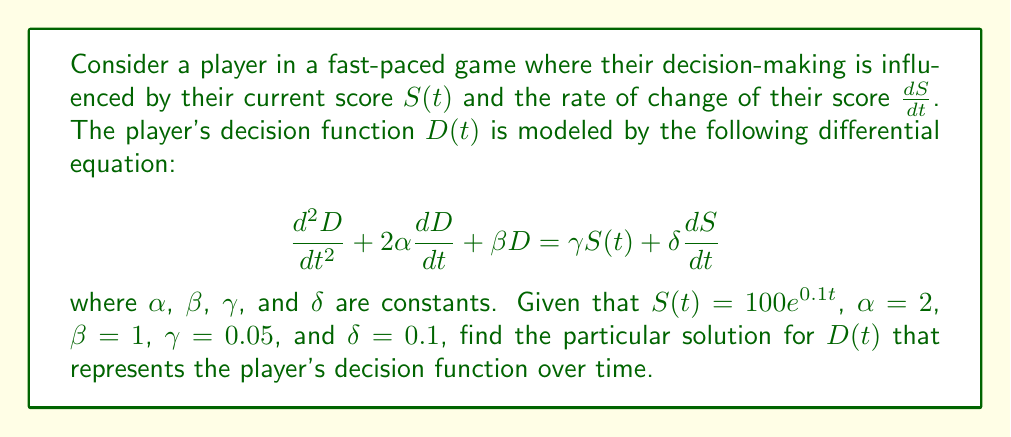Show me your answer to this math problem. To solve this problem, we'll follow these steps:

1) First, we need to find $\frac{dS}{dt}$:
   $S(t) = 100e^{0.1t}$
   $\frac{dS}{dt} = 10e^{0.1t}$

2) Now, we can substitute these into our differential equation:

   $$\frac{d^2D}{dt^2} + 4\frac{dD}{dt} + D = 0.05(100e^{0.1t}) + 0.1(10e^{0.1t})$$
   
   $$\frac{d^2D}{dt^2} + 4\frac{dD}{dt} + D = 5e^{0.1t} + e^{0.1t} = 6e^{0.1t}$$

3) The general solution to this equation will be the sum of the homogeneous solution and the particular solution. The homogeneous solution is of the form $D_h(t) = c_1e^{m_1t} + c_2e^{m_2t}$, where $m_1$ and $m_2$ are roots of the characteristic equation $m^2 + 4m + 1 = 0$.

4) For the particular solution, we assume a form $D_p(t) = Ae^{0.1t}$, where $A$ is a constant to be determined.

5) Substituting $D_p(t)$ into the left side of the differential equation:

   $$\frac{d^2D_p}{dt^2} + 4\frac{dD_p}{dt} + D_p = (0.01A + 0.4A + A)e^{0.1t} = 1.41Ae^{0.1t}$$

6) Equating this to the right side of the equation:

   $$1.41Ae^{0.1t} = 6e^{0.1t}$$

7) Solving for $A$:

   $$A = \frac{6}{1.41} \approx 4.2553$$

Therefore, the particular solution is:

$$D_p(t) \approx 4.2553e^{0.1t}$$

This represents the player's decision function over time, showing how their decision-making adapts based on their increasing score.
Answer: $D_p(t) \approx 4.2553e^{0.1t}$ 